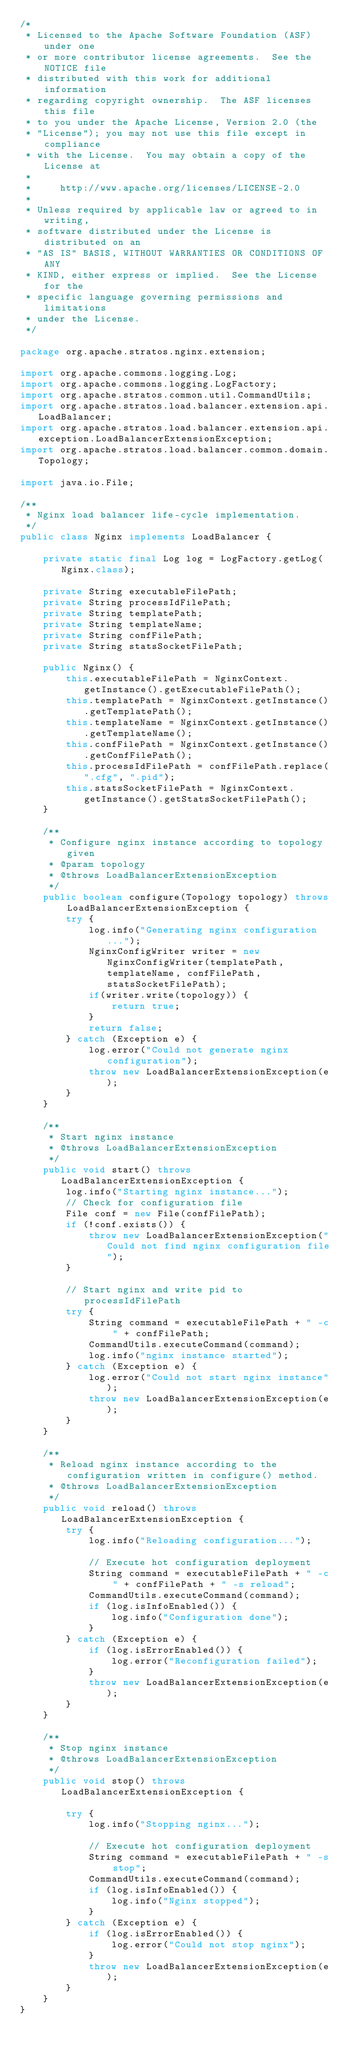Convert code to text. <code><loc_0><loc_0><loc_500><loc_500><_Java_>/*
 * Licensed to the Apache Software Foundation (ASF) under one
 * or more contributor license agreements.  See the NOTICE file
 * distributed with this work for additional information
 * regarding copyright ownership.  The ASF licenses this file
 * to you under the Apache License, Version 2.0 (the
 * "License"); you may not use this file except in compliance
 * with the License.  You may obtain a copy of the License at
 *
 *     http://www.apache.org/licenses/LICENSE-2.0
 *
 * Unless required by applicable law or agreed to in writing,
 * software distributed under the License is distributed on an
 * "AS IS" BASIS, WITHOUT WARRANTIES OR CONDITIONS OF ANY
 * KIND, either express or implied.  See the License for the
 * specific language governing permissions and limitations
 * under the License.
 */

package org.apache.stratos.nginx.extension;

import org.apache.commons.logging.Log;
import org.apache.commons.logging.LogFactory;
import org.apache.stratos.common.util.CommandUtils;
import org.apache.stratos.load.balancer.extension.api.LoadBalancer;
import org.apache.stratos.load.balancer.extension.api.exception.LoadBalancerExtensionException;
import org.apache.stratos.load.balancer.common.domain.Topology;

import java.io.File;

/**
 * Nginx load balancer life-cycle implementation.
 */
public class Nginx implements LoadBalancer {

    private static final Log log = LogFactory.getLog(Nginx.class);

    private String executableFilePath;
    private String processIdFilePath;
    private String templatePath;
    private String templateName;
    private String confFilePath;
    private String statsSocketFilePath;

    public Nginx() {
        this.executableFilePath = NginxContext.getInstance().getExecutableFilePath();
        this.templatePath = NginxContext.getInstance().getTemplatePath();
        this.templateName = NginxContext.getInstance().getTemplateName();
        this.confFilePath = NginxContext.getInstance().getConfFilePath();
        this.processIdFilePath = confFilePath.replace(".cfg", ".pid");
        this.statsSocketFilePath = NginxContext.getInstance().getStatsSocketFilePath();
    }

    /**
     * Configure nginx instance according to topology given
     * @param topology
     * @throws LoadBalancerExtensionException
     */
    public boolean configure(Topology topology) throws LoadBalancerExtensionException {
        try {
            log.info("Generating nginx configuration...");
            NginxConfigWriter writer = new NginxConfigWriter(templatePath, templateName, confFilePath, statsSocketFilePath);
            if(writer.write(topology)) {
                return true;
            }
            return false;
        } catch (Exception e) {
            log.error("Could not generate nginx configuration");
            throw new LoadBalancerExtensionException(e);
        }
    }

    /**
     * Start nginx instance
     * @throws LoadBalancerExtensionException
     */
    public void start() throws LoadBalancerExtensionException {
        log.info("Starting nginx instance...");
        // Check for configuration file
        File conf = new File(confFilePath);
        if (!conf.exists()) {
            throw new LoadBalancerExtensionException("Could not find nginx configuration file");
        }

        // Start nginx and write pid to processIdFilePath
        try {
            String command = executableFilePath + " -c " + confFilePath;
            CommandUtils.executeCommand(command);
            log.info("nginx instance started");
        } catch (Exception e) {
            log.error("Could not start nginx instance");
            throw new LoadBalancerExtensionException(e);
        }
    }

    /**
     * Reload nginx instance according to the configuration written in configure() method.
     * @throws LoadBalancerExtensionException
     */
    public void reload() throws LoadBalancerExtensionException {
        try {
            log.info("Reloading configuration...");

            // Execute hot configuration deployment
            String command = executableFilePath + " -c " + confFilePath + " -s reload";
            CommandUtils.executeCommand(command);
            if (log.isInfoEnabled()) {
                log.info("Configuration done");
            }
        } catch (Exception e) {
            if (log.isErrorEnabled()) {
                log.error("Reconfiguration failed");
            }
            throw new LoadBalancerExtensionException(e);
        }
    }

    /**
     * Stop nginx instance
     * @throws LoadBalancerExtensionException
     */
    public void stop() throws LoadBalancerExtensionException {

        try {
            log.info("Stopping nginx...");

            // Execute hot configuration deployment
            String command = executableFilePath + " -s stop";
            CommandUtils.executeCommand(command);
            if (log.isInfoEnabled()) {
                log.info("Nginx stopped");
            }
        } catch (Exception e) {
            if (log.isErrorEnabled()) {
                log.error("Could not stop nginx");
            }
            throw new LoadBalancerExtensionException(e);
        }
    }
}
</code> 